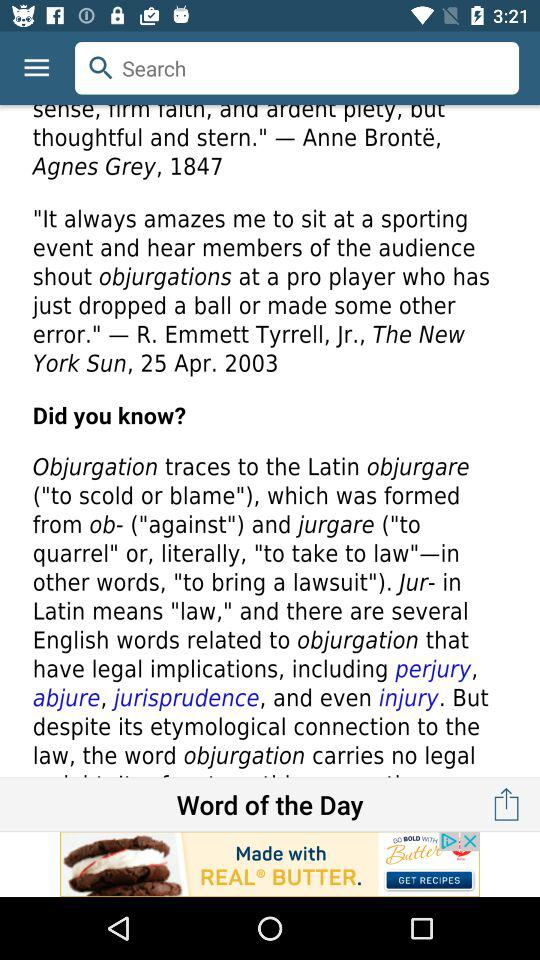What is the meaning of the Latin word "objurgare"? The meaning is "to scold or blame". 